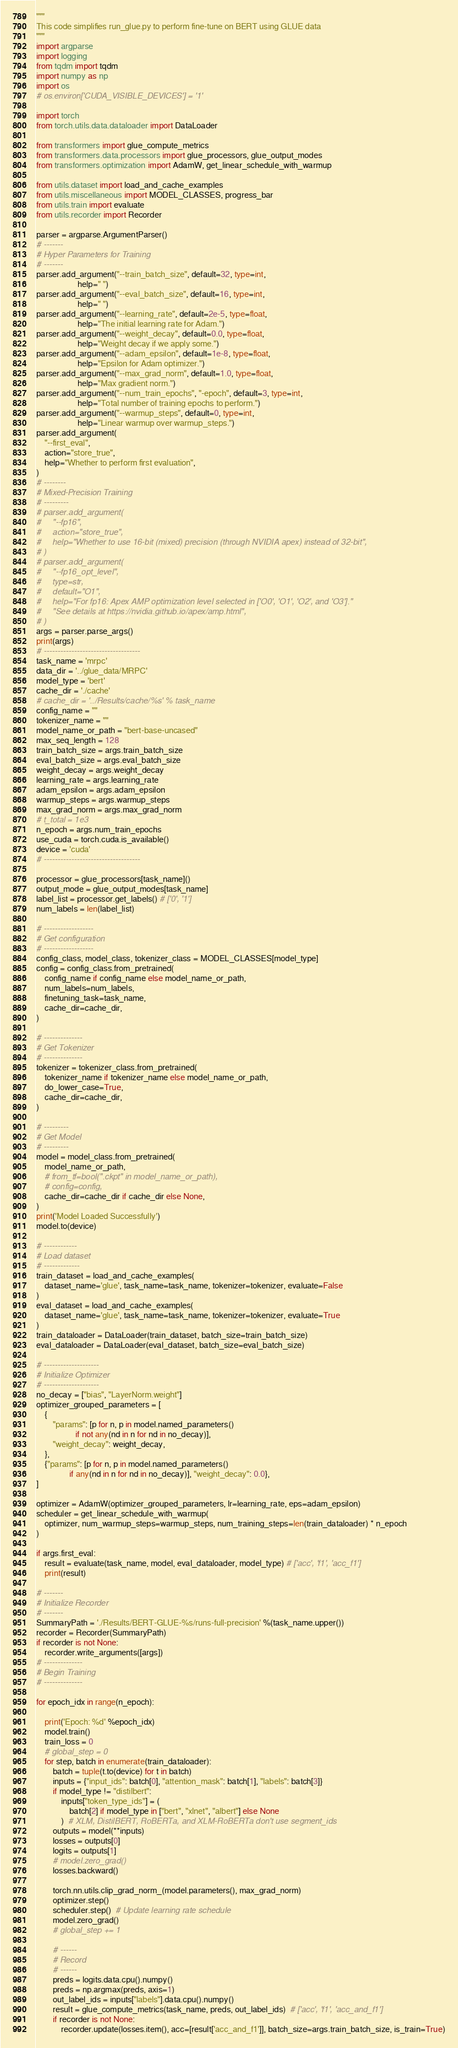Convert code to text. <code><loc_0><loc_0><loc_500><loc_500><_Python_>"""
This code simplifies run_glue.py to perform fine-tune on BERT using GLUE data
"""
import argparse
import logging
from tqdm import tqdm
import numpy as np
import os
# os.environ['CUDA_VISIBLE_DEVICES'] = '1'

import torch
from torch.utils.data.dataloader import DataLoader

from transformers import glue_compute_metrics
from transformers.data.processors import glue_processors, glue_output_modes
from transformers.optimization import AdamW, get_linear_schedule_with_warmup

from utils.dataset import load_and_cache_examples
from utils.miscellaneous import MODEL_CLASSES, progress_bar
from utils.train import evaluate
from utils.recorder import Recorder

parser = argparse.ArgumentParser()
# -------
# Hyper Parameters for Training
# -------
parser.add_argument("--train_batch_size", default=32, type=int,
                    help=" ")
parser.add_argument("--eval_batch_size", default=16, type=int,
                    help=" ")
parser.add_argument("--learning_rate", default=2e-5, type=float,
                    help="The initial learning rate for Adam.")
parser.add_argument("--weight_decay", default=0.0, type=float,
                    help="Weight decay if we apply some.")
parser.add_argument("--adam_epsilon", default=1e-8, type=float,
                    help="Epsilon for Adam optimizer.")
parser.add_argument("--max_grad_norm", default=1.0, type=float,
                    help="Max gradient norm.")
parser.add_argument("--num_train_epochs", "-epoch", default=3, type=int,
                    help="Total number of training epochs to perform.")
parser.add_argument("--warmup_steps", default=0, type=int,
                    help="Linear warmup over warmup_steps.")
parser.add_argument(
    "--first_eval",
    action="store_true",
    help="Whether to perform first evaluation",
)
# --------
# Mixed-Precision Training
# ---------
# parser.add_argument(
#     "--fp16",
#     action="store_true",
#     help="Whether to use 16-bit (mixed) precision (through NVIDIA apex) instead of 32-bit",
# )
# parser.add_argument(
#     "--fp16_opt_level",
#     type=str,
#     default="O1",
#     help="For fp16: Apex AMP optimization level selected in ['O0', 'O1', 'O2', and 'O3']."
#     "See details at https://nvidia.github.io/apex/amp.html",
# )
args = parser.parse_args()
print(args)
# -----------------------------------
task_name = 'mrpc'
data_dir = '../glue_data/MRPC'
model_type = 'bert'
cache_dir = './cache'
# cache_dir = '../Results/cache/%s' % task_name
config_name = ""
tokenizer_name = ""
model_name_or_path = "bert-base-uncased"
max_seq_length = 128
train_batch_size = args.train_batch_size
eval_batch_size = args.eval_batch_size
weight_decay = args.weight_decay
learning_rate = args.learning_rate
adam_epsilon = args.adam_epsilon
warmup_steps = args.warmup_steps
max_grad_norm = args.max_grad_norm
# t_total = 1e3
n_epoch = args.num_train_epochs
use_cuda = torch.cuda.is_available()
device = 'cuda'
# -----------------------------------

processor = glue_processors[task_name]()
output_mode = glue_output_modes[task_name]
label_list = processor.get_labels() # ['0', '1']
num_labels = len(label_list)

# ------------------
# Get configuration
# ------------------
config_class, model_class, tokenizer_class = MODEL_CLASSES[model_type]
config = config_class.from_pretrained(
    config_name if config_name else model_name_or_path,
    num_labels=num_labels,
    finetuning_task=task_name,
    cache_dir=cache_dir,
)

# --------------
# Get Tokenizer
# --------------
tokenizer = tokenizer_class.from_pretrained(
    tokenizer_name if tokenizer_name else model_name_or_path,
    do_lower_case=True,
    cache_dir=cache_dir,
)

# ---------
# Get Model
# ---------
model = model_class.from_pretrained(
    model_name_or_path,
    # from_tf=bool(".ckpt" in model_name_or_path),
    # config=config,
    cache_dir=cache_dir if cache_dir else None,
)
print('Model Loaded Successfully')
model.to(device)

# ------------
# Load dataset
# -------------
train_dataset = load_and_cache_examples(
    dataset_name='glue', task_name=task_name, tokenizer=tokenizer, evaluate=False
)
eval_dataset = load_and_cache_examples(
    dataset_name='glue', task_name=task_name, tokenizer=tokenizer, evaluate=True
)
train_dataloader = DataLoader(train_dataset, batch_size=train_batch_size)
eval_dataloader = DataLoader(eval_dataset, batch_size=eval_batch_size)

# --------------------
# Initialize Optimizer
# --------------------
no_decay = ["bias", "LayerNorm.weight"]
optimizer_grouped_parameters = [
    {
        "params": [p for n, p in model.named_parameters()
                   if not any(nd in n for nd in no_decay)],
        "weight_decay": weight_decay,
    },
    {"params": [p for n, p in model.named_parameters()
                if any(nd in n for nd in no_decay)], "weight_decay": 0.0},
]

optimizer = AdamW(optimizer_grouped_parameters, lr=learning_rate, eps=adam_epsilon)
scheduler = get_linear_schedule_with_warmup(
    optimizer, num_warmup_steps=warmup_steps, num_training_steps=len(train_dataloader) * n_epoch
)

if args.first_eval:
    result = evaluate(task_name, model, eval_dataloader, model_type) # ['acc', 'f1', 'acc_f1']
    print(result)

# -------
# Initialize Recorder
# -------
SummaryPath = './Results/BERT-GLUE-%s/runs-full-precision' %(task_name.upper())
recorder = Recorder(SummaryPath)
if recorder is not None:
    recorder.write_arguments([args])
# --------------
# Begin Training
# --------------

for epoch_idx in range(n_epoch):

    print('Epoch: %d' %epoch_idx)
    model.train()
    train_loss = 0
    # global_step = 0
    for step, batch in enumerate(train_dataloader):
        batch = tuple(t.to(device) for t in batch)
        inputs = {"input_ids": batch[0], "attention_mask": batch[1], "labels": batch[3]}
        if model_type != "distilbert":
            inputs["token_type_ids"] = (
                batch[2] if model_type in ["bert", "xlnet", "albert"] else None
            )  # XLM, DistilBERT, RoBERTa, and XLM-RoBERTa don't use segment_ids
        outputs = model(**inputs)
        losses = outputs[0]
        logits = outputs[1]
        # model.zero_grad()
        losses.backward()

        torch.nn.utils.clip_grad_norm_(model.parameters(), max_grad_norm)
        optimizer.step()
        scheduler.step()  # Update learning rate schedule
        model.zero_grad()
        # global_step += 1

        # ------
        # Record
        # ------
        preds = logits.data.cpu().numpy()
        preds = np.argmax(preds, axis=1)
        out_label_ids = inputs["labels"].data.cpu().numpy()
        result = glue_compute_metrics(task_name, preds, out_label_ids)  # ['acc', 'f1', 'acc_and_f1']
        if recorder is not None:
            recorder.update(losses.item(), acc=[result['acc_and_f1']], batch_size=args.train_batch_size, is_train=True)</code> 